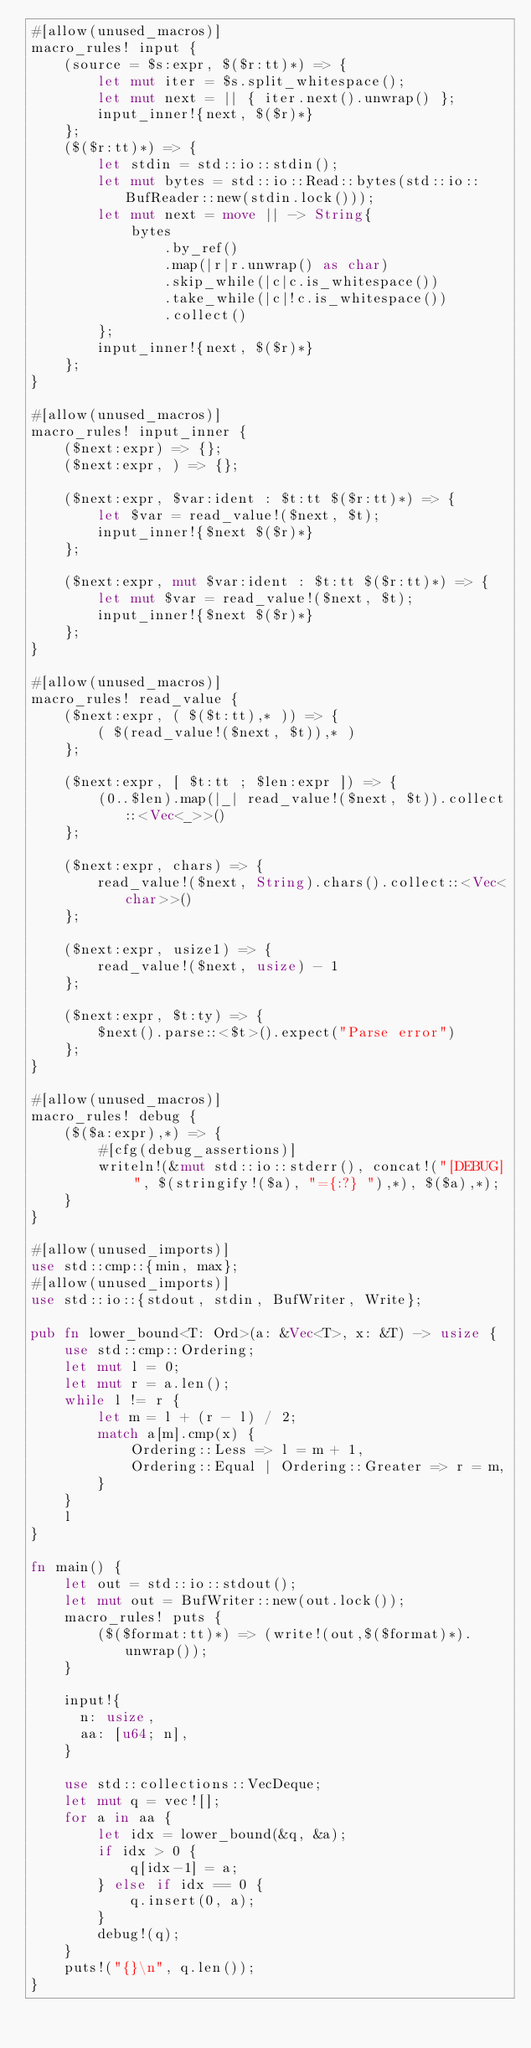<code> <loc_0><loc_0><loc_500><loc_500><_Rust_>#[allow(unused_macros)]
macro_rules! input {
    (source = $s:expr, $($r:tt)*) => {
        let mut iter = $s.split_whitespace();
        let mut next = || { iter.next().unwrap() };
        input_inner!{next, $($r)*}
    };
    ($($r:tt)*) => {
        let stdin = std::io::stdin();
        let mut bytes = std::io::Read::bytes(std::io::BufReader::new(stdin.lock()));
        let mut next = move || -> String{
            bytes
                .by_ref()
                .map(|r|r.unwrap() as char)
                .skip_while(|c|c.is_whitespace())
                .take_while(|c|!c.is_whitespace())
                .collect()
        };
        input_inner!{next, $($r)*}
    };
}

#[allow(unused_macros)]
macro_rules! input_inner {
    ($next:expr) => {};
    ($next:expr, ) => {};

    ($next:expr, $var:ident : $t:tt $($r:tt)*) => {
        let $var = read_value!($next, $t);
        input_inner!{$next $($r)*}
    };

    ($next:expr, mut $var:ident : $t:tt $($r:tt)*) => {
        let mut $var = read_value!($next, $t);
        input_inner!{$next $($r)*}
    };
}

#[allow(unused_macros)]
macro_rules! read_value {
    ($next:expr, ( $($t:tt),* )) => {
        ( $(read_value!($next, $t)),* )
    };

    ($next:expr, [ $t:tt ; $len:expr ]) => {
        (0..$len).map(|_| read_value!($next, $t)).collect::<Vec<_>>()
    };

    ($next:expr, chars) => {
        read_value!($next, String).chars().collect::<Vec<char>>()
    };

    ($next:expr, usize1) => {
        read_value!($next, usize) - 1
    };

    ($next:expr, $t:ty) => {
        $next().parse::<$t>().expect("Parse error")
    };
}

#[allow(unused_macros)]
macro_rules! debug {
    ($($a:expr),*) => {
        #[cfg(debug_assertions)]
        writeln!(&mut std::io::stderr(), concat!("[DEBUG] ", $(stringify!($a), "={:?} "),*), $($a),*);
    }
}

#[allow(unused_imports)]
use std::cmp::{min, max};
#[allow(unused_imports)]
use std::io::{stdout, stdin, BufWriter, Write};

pub fn lower_bound<T: Ord>(a: &Vec<T>, x: &T) -> usize {
    use std::cmp::Ordering;
    let mut l = 0;
    let mut r = a.len();
    while l != r {
        let m = l + (r - l) / 2;
        match a[m].cmp(x) {
            Ordering::Less => l = m + 1,
            Ordering::Equal | Ordering::Greater => r = m,
        }
    }
    l
}

fn main() {
    let out = std::io::stdout();
    let mut out = BufWriter::new(out.lock());
    macro_rules! puts {
        ($($format:tt)*) => (write!(out,$($format)*).unwrap());
    }

    input!{
      n: usize,
      aa: [u64; n],
    }

    use std::collections::VecDeque;
    let mut q = vec![];
    for a in aa {
        let idx = lower_bound(&q, &a);
        if idx > 0 {
            q[idx-1] = a;
        } else if idx == 0 {
            q.insert(0, a);
        }
        debug!(q);
    }
    puts!("{}\n", q.len());
}
</code> 